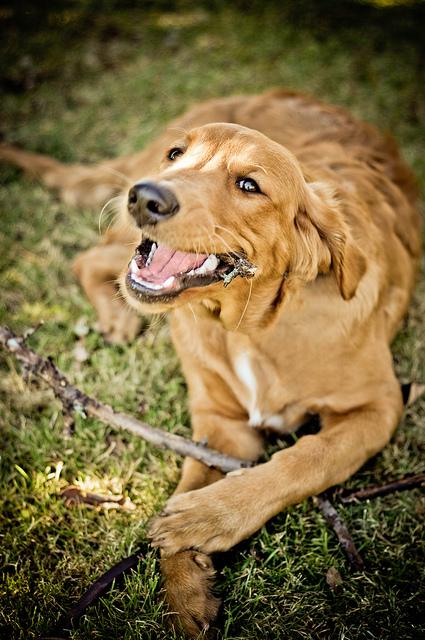Is the dog barking?
Keep it brief. No. Is this dog's fur getting wet?
Answer briefly. No. Who is a bad dog?
Short answer required. No. Is the dog wearing a collar?
Concise answer only. No. Is the dog running?
Quick response, please. No. Does the dog have long ears?
Quick response, please. Yes. What is the puppy chewing on?
Be succinct. Stick. What breed of dog is that?
Keep it brief. Golden retriever. Is this dog excited?
Quick response, please. Yes. Is the dog holding a frisbee?
Be succinct. No. How is the dog's tail?
Be succinct. Long. What kind of dog is this?
Keep it brief. Golden retriever. What is this dog doing?
Answer briefly. Panting. What is this dog chewing on?
Be succinct. Stick. How many dogs are seen?
Write a very short answer. 1. Is the dog brushing its teeth?
Concise answer only. No. What breed of dog is this?
Be succinct. Golden retriever. Is this dog barking?
Quick response, please. No. Is this picture staged or candid?
Answer briefly. Candid. What is the dog doing?
Concise answer only. Smiling. What is the dog holding in his mouth?
Write a very short answer. Nothing. Is the dog happy?
Answer briefly. Yes. What color is the dog?
Give a very brief answer. Brown. What is the dog chewing on?
Be succinct. Stick. What is the dog holding in his paws?
Write a very short answer. Stick. Is this an adult animal?
Quick response, please. Yes. 